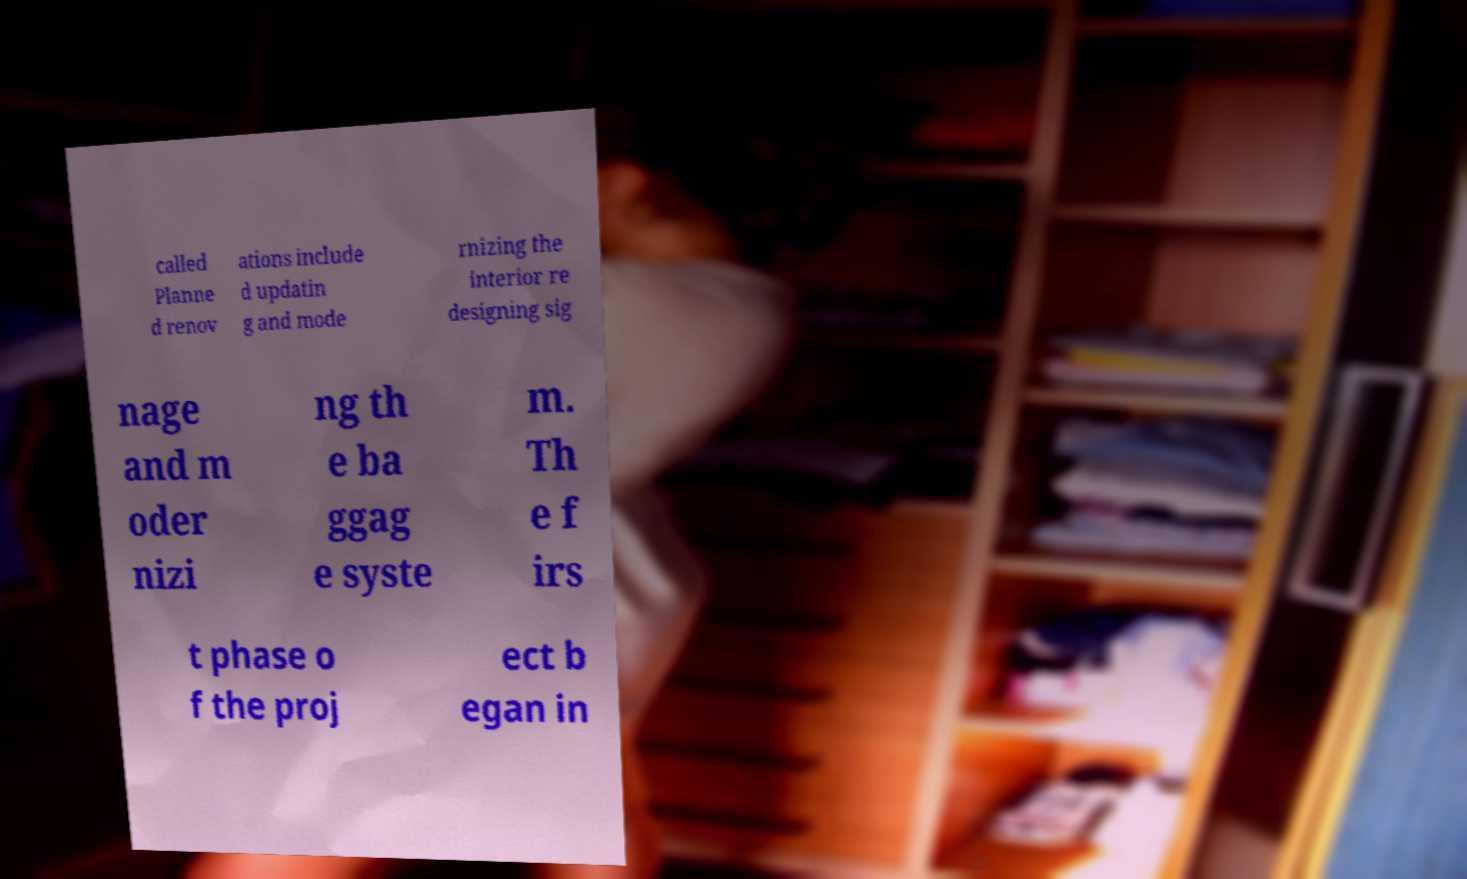Can you accurately transcribe the text from the provided image for me? called Planne d renov ations include d updatin g and mode rnizing the interior re designing sig nage and m oder nizi ng th e ba ggag e syste m. Th e f irs t phase o f the proj ect b egan in 